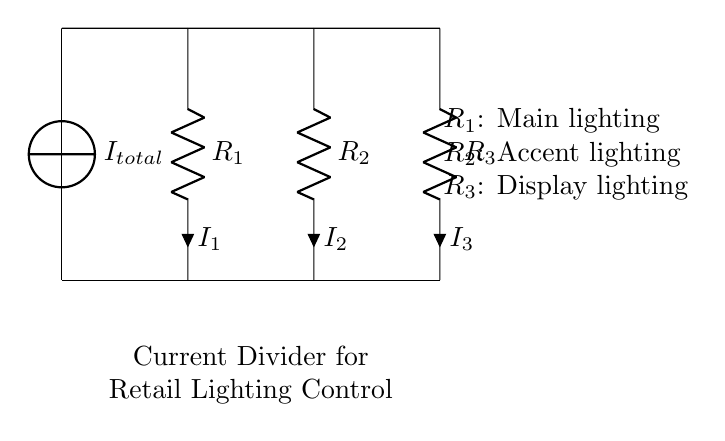What is the total current in this circuit? The total current is indicated as \( I_{total} \) in the circuit diagram. This is the current supplied by the current source.
Answer: \( I_{total} \) How many resistors are present in this current divider? The circuit diagram shows three resistors labeled \( R_1 \), \( R_2 \), and \( R_3 \). Each resistor represents a branch of the current divider.
Answer: 3 What does \( R_1 \) control in the lighting setup? Resistor \( R_1 \) is labeled as the main lighting, indicating that it controls the intensity of the primary lights used in the retail space.
Answer: Main lighting Which branch will carry the most current if all resistors are equal? If all resistors are equal, the current would distribute equally. Therefore, all branches would share the total current equally, but specifically, since \( R_1 \) is the first branch, it will carry the total divided current.
Answer: \( R_1 \) What is the purpose of the current divider configuration in this circuit? The current divider set up is used to manage different lighting intensities by dividing the total current among the resistors. Each resistor corresponds to a specific type of lighting (main, accent, display).
Answer: Manage lighting intensity What happens to the current through \( R_2 \) if \( R_1 \) is decreased? If \( R_1 \) is decreased (lower resistance), it will allow more total current to flow; therefore, less current will flow through \( R_2 \), as total current divides based on the resistances.
Answer: Decreases current through \( R_2 \) How does this circuit affect energy consumption in a retail space? By using the current divider, the owner can adjust the intensity of the lighting based on needs, allowing for energy savings when lower lighting is sufficient, hence optimizing energy usage according to specific store requirements.
Answer: Optimizes energy consumption 